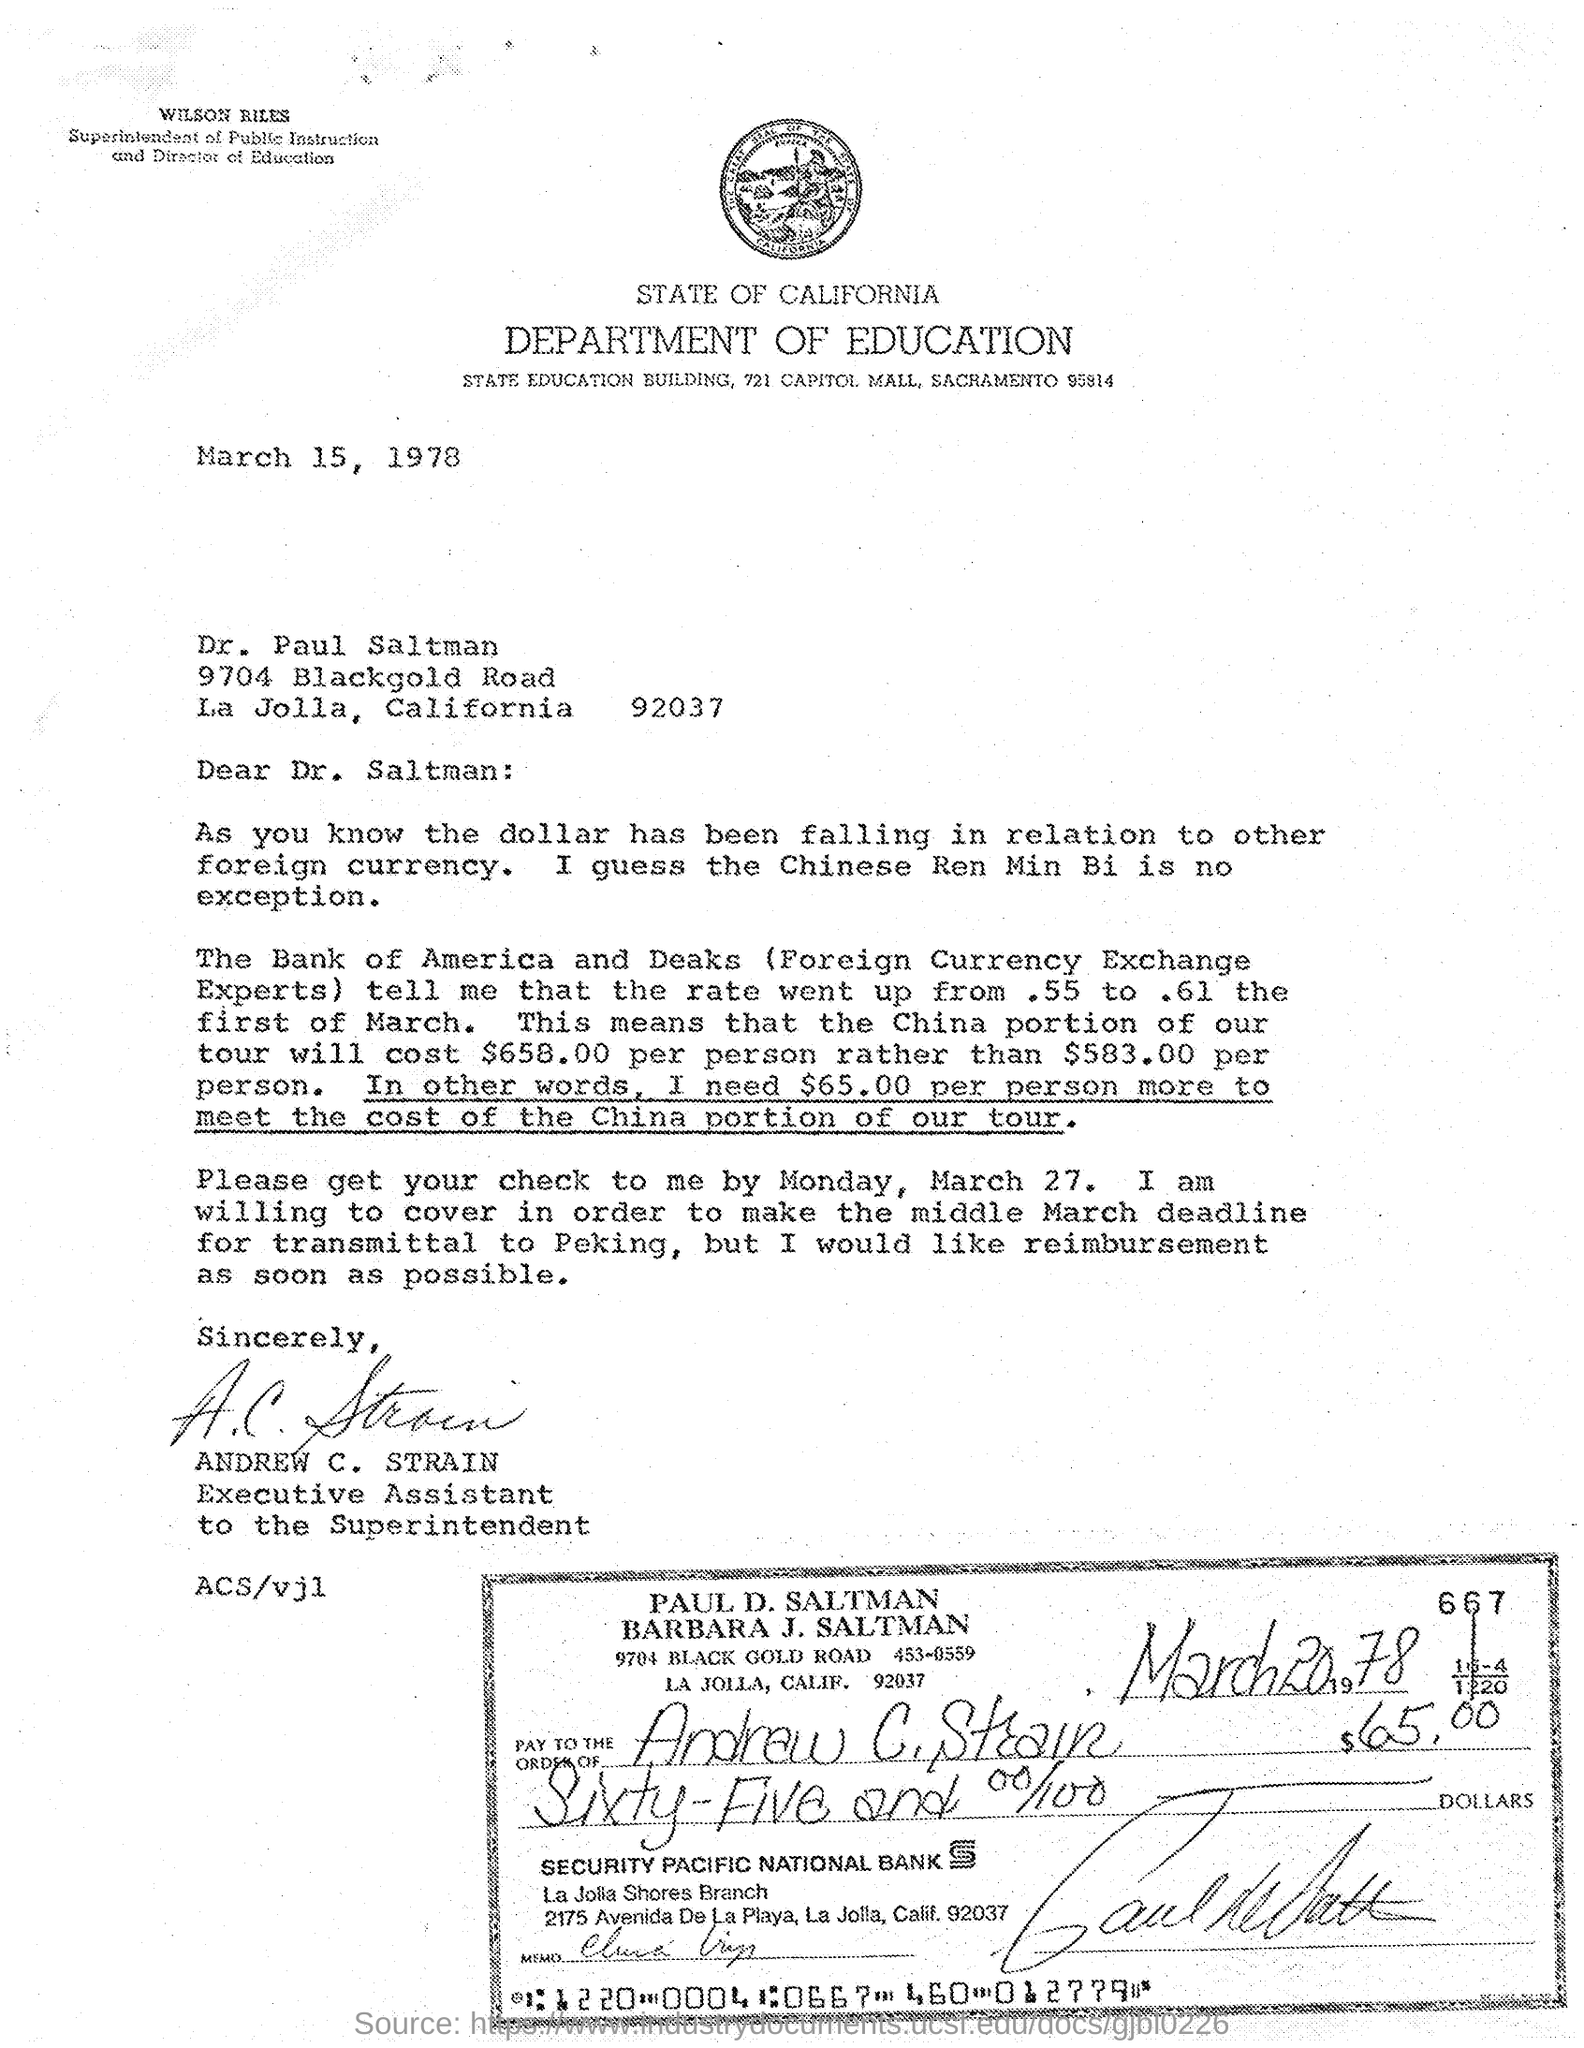Specify some key components in this picture. The Superintendent of Public Instruction is Wilson Riles. Andrew C. Strain is the executive assistant. The cheque mentions Security Pacific National Bank. This letter is from the Department of Education. 